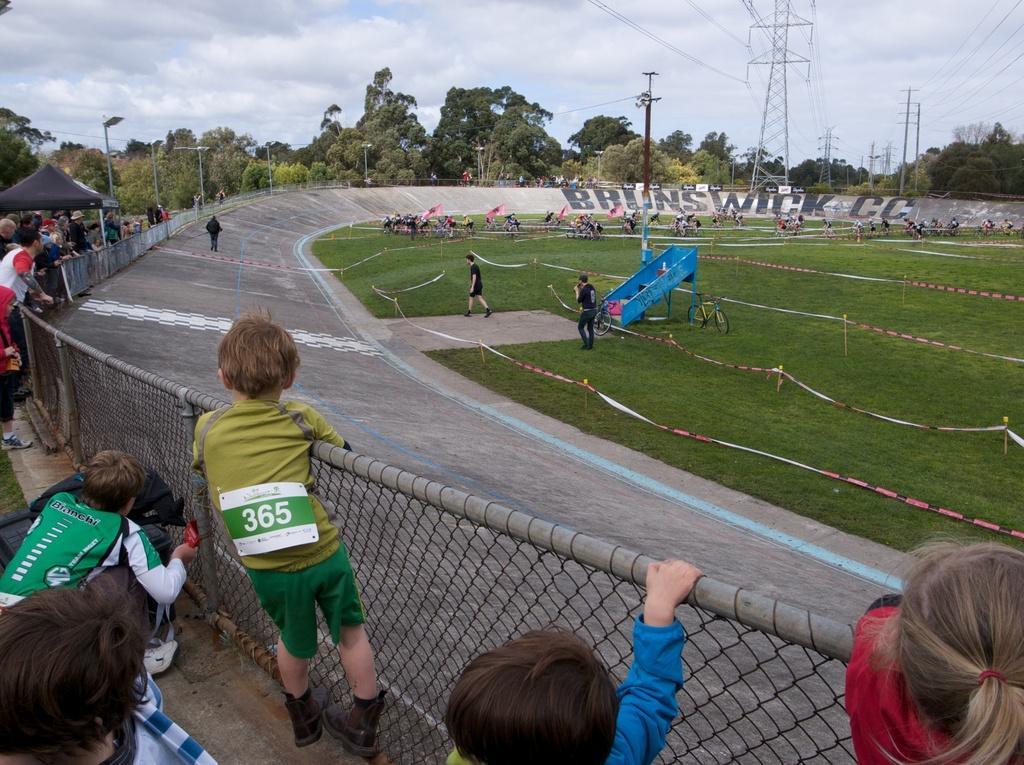Describe this image in one or two sentences. This is an outside view. On the right side, I can see many people are riding the bicycles on the ground and also I can see the grass. Around this ground I can see a road. Beside the road there is a net fencing. On the left side many people are standing and looking at the ground. In the background there are many poles and trees. At the top, I can see the sky. 